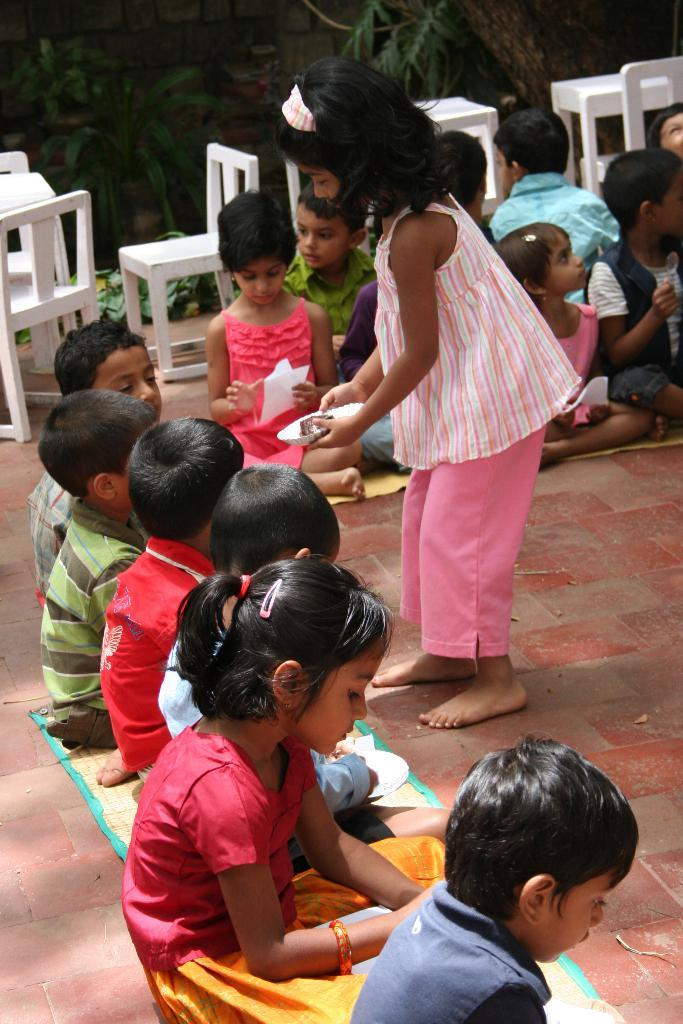How many children are in the image? There are children in the image, but the exact number is not specified. What are the children doing in the image? Some children are sitting, and one is standing. What are the children wearing in the image? The children are wearing clothes. What type of furniture is present in the image? There are chairs in the image. What is the surface beneath the children's feet in the image? There is a floor visible in the image. What type of vegetation is present in the image? Leaves are present in the image. What type of sign can be seen on the children's jeans in the image? There is no mention of jeans or a sign in the image; the children are simply wearing clothes. 